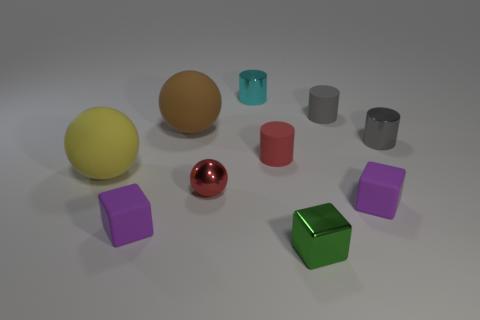Is the size of the cyan metal thing the same as the purple rubber cube to the left of the cyan cylinder?
Provide a succinct answer. Yes. There is a large object in front of the red object right of the small metallic ball; what is its color?
Your answer should be very brief. Yellow. What number of other objects are there of the same color as the small metal block?
Make the answer very short. 0. The gray metallic thing has what size?
Your answer should be very brief. Small. Are there more shiny things in front of the gray metallic thing than tiny red balls that are left of the small green shiny block?
Provide a short and direct response. Yes. How many tiny matte objects are in front of the yellow object that is in front of the small cyan metallic object?
Your answer should be compact. 2. Is the shape of the tiny purple matte thing left of the small ball the same as  the cyan shiny object?
Offer a terse response. No. There is a small red thing that is the same shape as the tiny cyan metallic thing; what is it made of?
Give a very brief answer. Rubber. What number of other rubber things are the same size as the brown matte object?
Offer a terse response. 1. There is a sphere that is in front of the brown rubber sphere and to the right of the yellow ball; what is its color?
Make the answer very short. Red. 